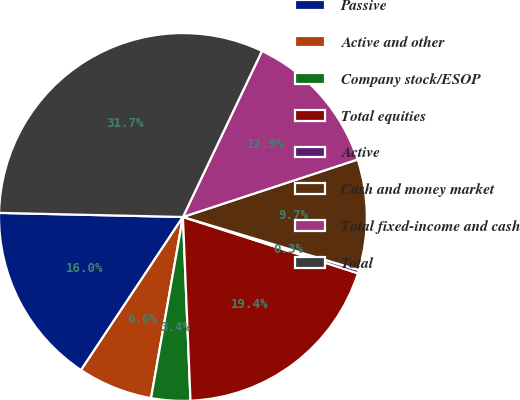<chart> <loc_0><loc_0><loc_500><loc_500><pie_chart><fcel>Passive<fcel>Active and other<fcel>Company stock/ESOP<fcel>Total equities<fcel>Active<fcel>Cash and money market<fcel>Total fixed-income and cash<fcel>Total<nl><fcel>16.01%<fcel>6.57%<fcel>3.43%<fcel>19.39%<fcel>0.29%<fcel>9.72%<fcel>12.87%<fcel>31.72%<nl></chart> 